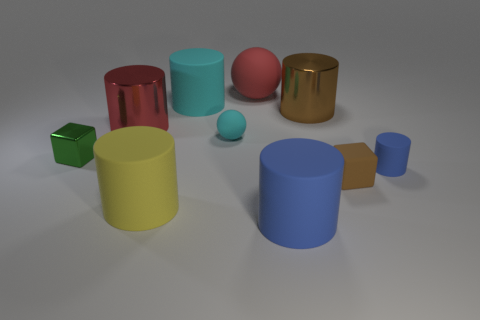There is a red rubber thing; are there any big yellow cylinders on the right side of it? no 